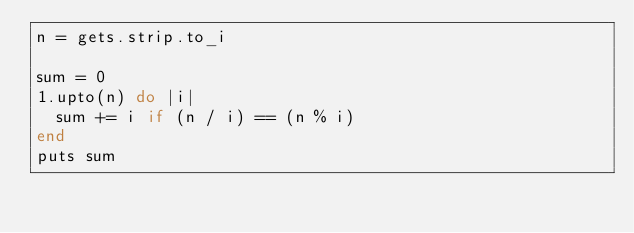Convert code to text. <code><loc_0><loc_0><loc_500><loc_500><_Ruby_>n = gets.strip.to_i

sum = 0
1.upto(n) do |i|
  sum += i if (n / i) == (n % i)
end
puts sum
</code> 